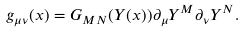<formula> <loc_0><loc_0><loc_500><loc_500>g _ { \mu \nu } ( x ) = G _ { M N } ( Y ( x ) ) \partial _ { \mu } Y ^ { M } \partial _ { \nu } Y ^ { N } .</formula> 